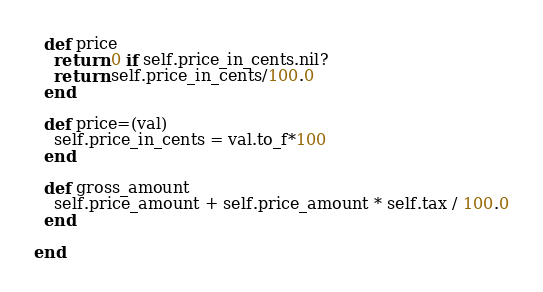Convert code to text. <code><loc_0><loc_0><loc_500><loc_500><_Ruby_>  def price
    return 0 if self.price_in_cents.nil?
    return self.price_in_cents/100.0
  end

  def price=(val)
    self.price_in_cents = val.to_f*100
  end
  
  def gross_amount
    self.price_amount + self.price_amount * self.tax / 100.0
  end

end
</code> 